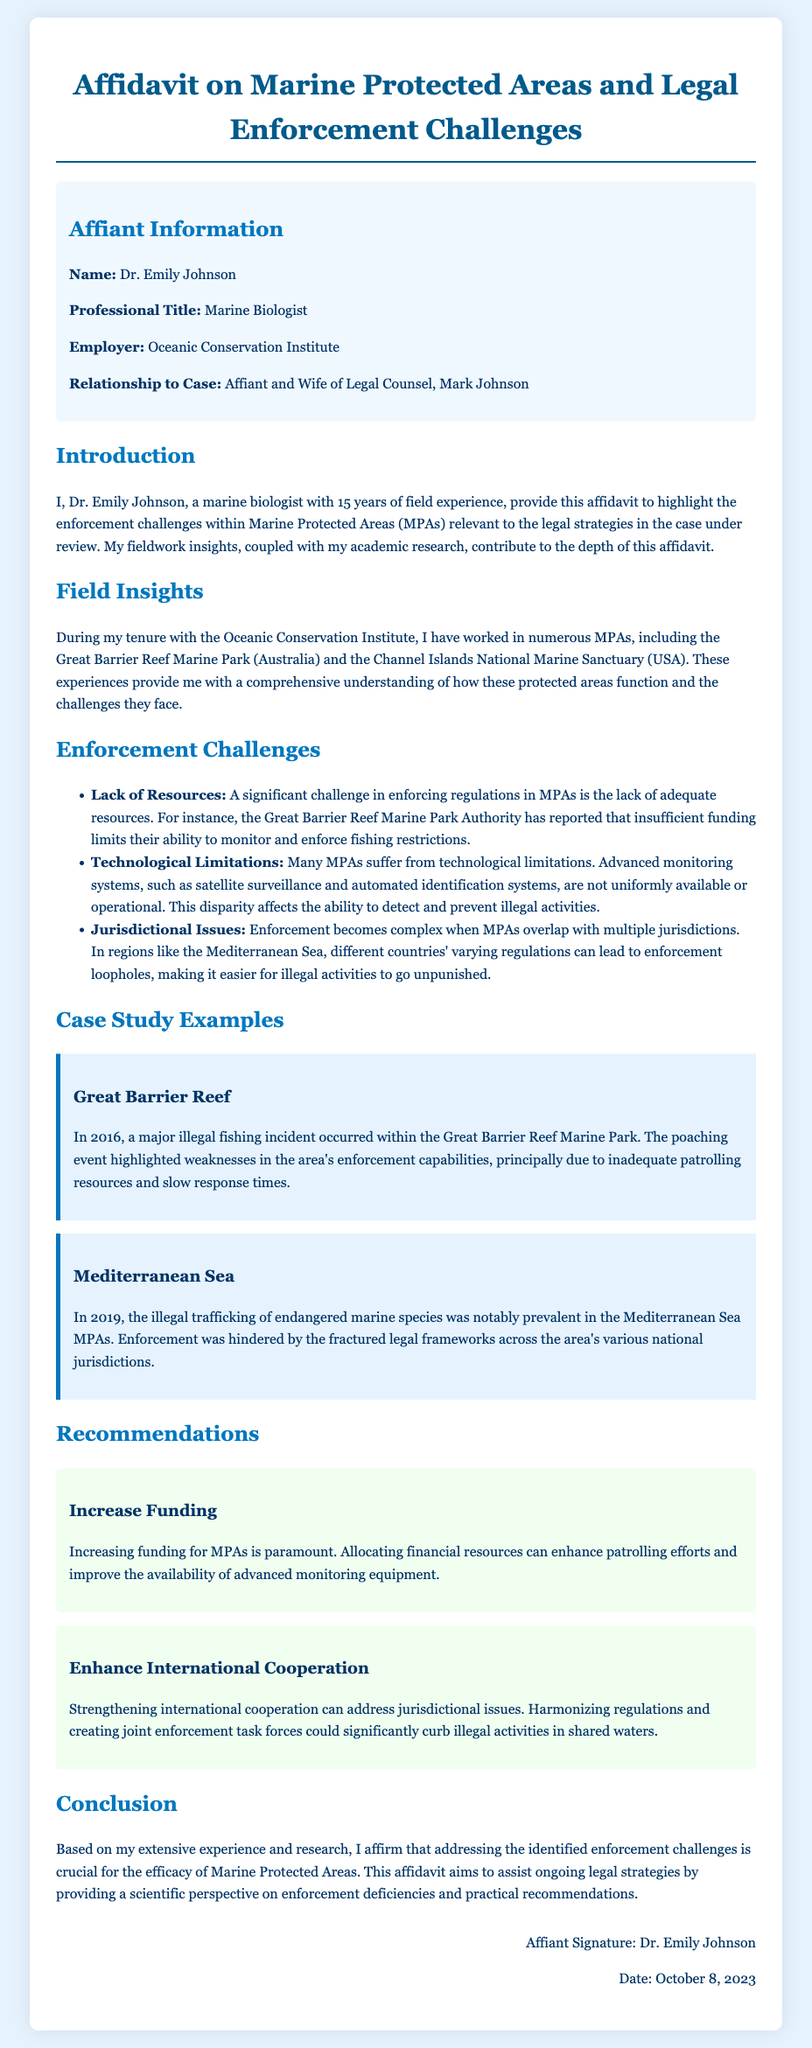What is the name of the affiant? The affiant's name is stated in the document, which is Dr. Emily Johnson.
Answer: Dr. Emily Johnson What is Dr. Emily Johnson's professional title? The document specifies her professional title, which is Marine Biologist.
Answer: Marine Biologist What organization does Dr. Emily Johnson work for? The document indicates her employer, which is the Oceanic Conservation Institute.
Answer: Oceanic Conservation Institute What is one enforcement challenge mentioned for MPAs? The document lists several challenges, one of which is Lack of Resources.
Answer: Lack of Resources In what year did the illegal fishing incident in the Great Barrier Reef occur? The document states that the incident occurred in 2016.
Answer: 2016 What is one recommendation given in the affidavit? The affidavit provides several recommendations, one being Increase Funding.
Answer: Increase Funding How many years of field experience does Dr. Emily Johnson have? The document mentions her experience duration, which is 15 years.
Answer: 15 years What is the date of the affidavit? The document concludes with the date on which it was signed, which is October 8, 2023.
Answer: October 8, 2023 What is the main focus of this affidavit? The document describes the focus of the affidavit as highlighting enforcement challenges within Marine Protected Areas (MPAs).
Answer: Enforcement challenges within Marine Protected Areas 